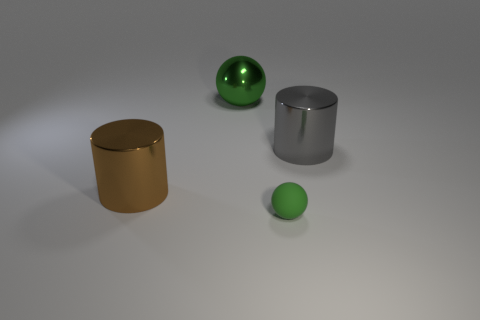How would you describe the overall mood or atmosphere of the image? The image projects a minimalist and serene ambiance. The soft lighting and muted background contribute to a calm and orderly scene, with the objects neatly placed and the absence of any chaotic elements. 